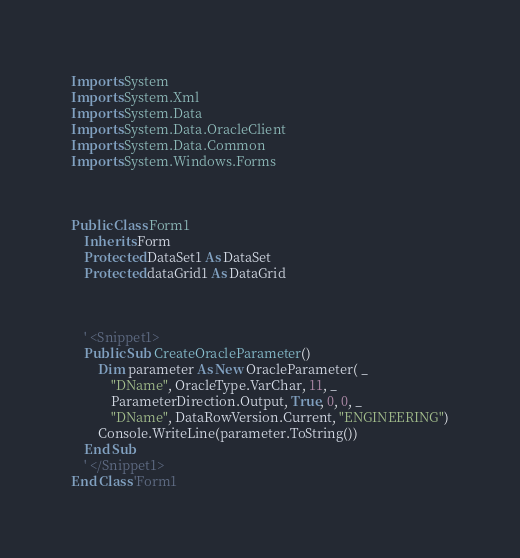Convert code to text. <code><loc_0><loc_0><loc_500><loc_500><_VisualBasic_>Imports System
Imports System.Xml
Imports System.Data
Imports System.Data.OracleClient
Imports System.Data.Common
Imports System.Windows.Forms



Public Class Form1
    Inherits Form
    Protected DataSet1 As DataSet
    Protected dataGrid1 As DataGrid
    
    
    
    ' <Snippet1>
    Public Sub CreateOracleParameter()
        Dim parameter As New OracleParameter( _
            "DName", OracleType.VarChar, 11, _
            ParameterDirection.Output, True, 0, 0, _
            "DName", DataRowVersion.Current, "ENGINEERING")
        Console.WriteLine(parameter.ToString())
    End Sub 
    ' </Snippet1>
End Class 'Form1 
</code> 